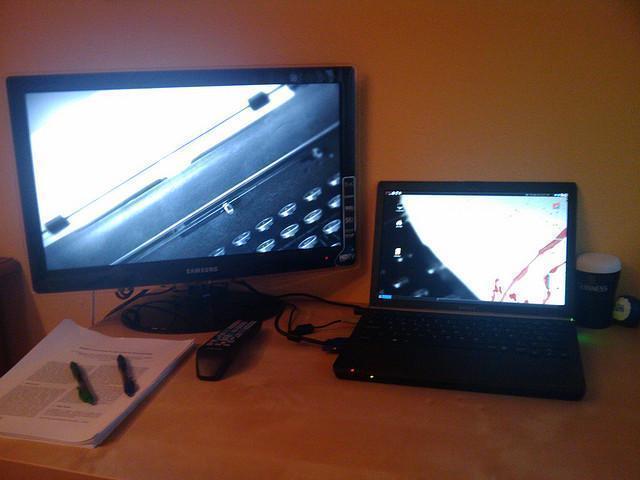By which technology standard is the monitor connected to the laptop?
Choose the right answer and clarify with the format: 'Answer: answer
Rationale: rationale.'
Options: Vga, dvi, displayport, hdmi. Answer: vga.
Rationale: It is an older interface. 